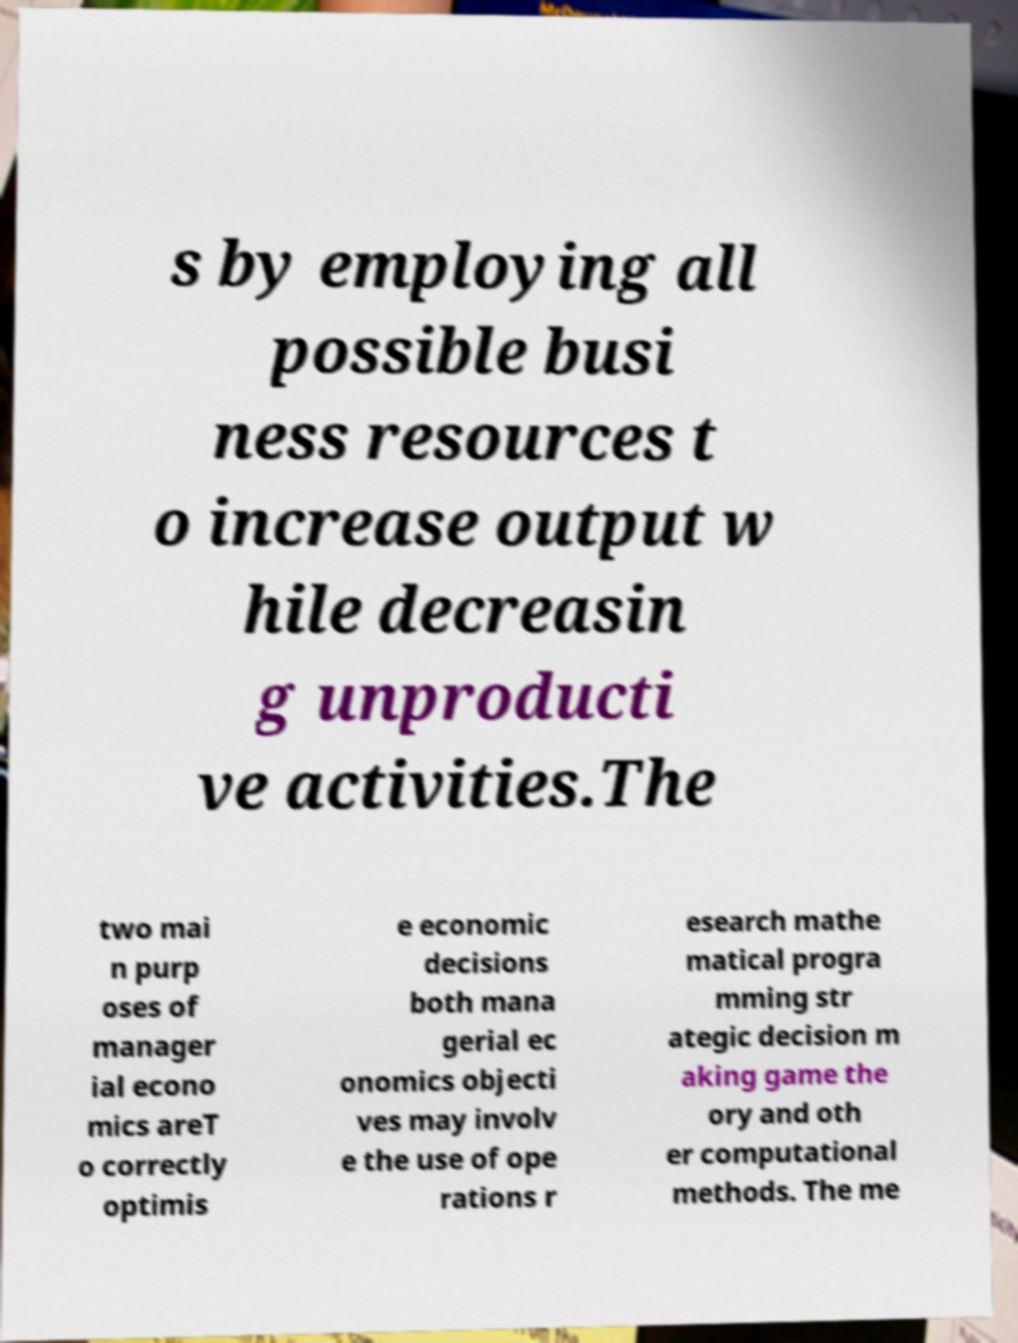Could you assist in decoding the text presented in this image and type it out clearly? s by employing all possible busi ness resources t o increase output w hile decreasin g unproducti ve activities.The two mai n purp oses of manager ial econo mics areT o correctly optimis e economic decisions both mana gerial ec onomics objecti ves may involv e the use of ope rations r esearch mathe matical progra mming str ategic decision m aking game the ory and oth er computational methods. The me 